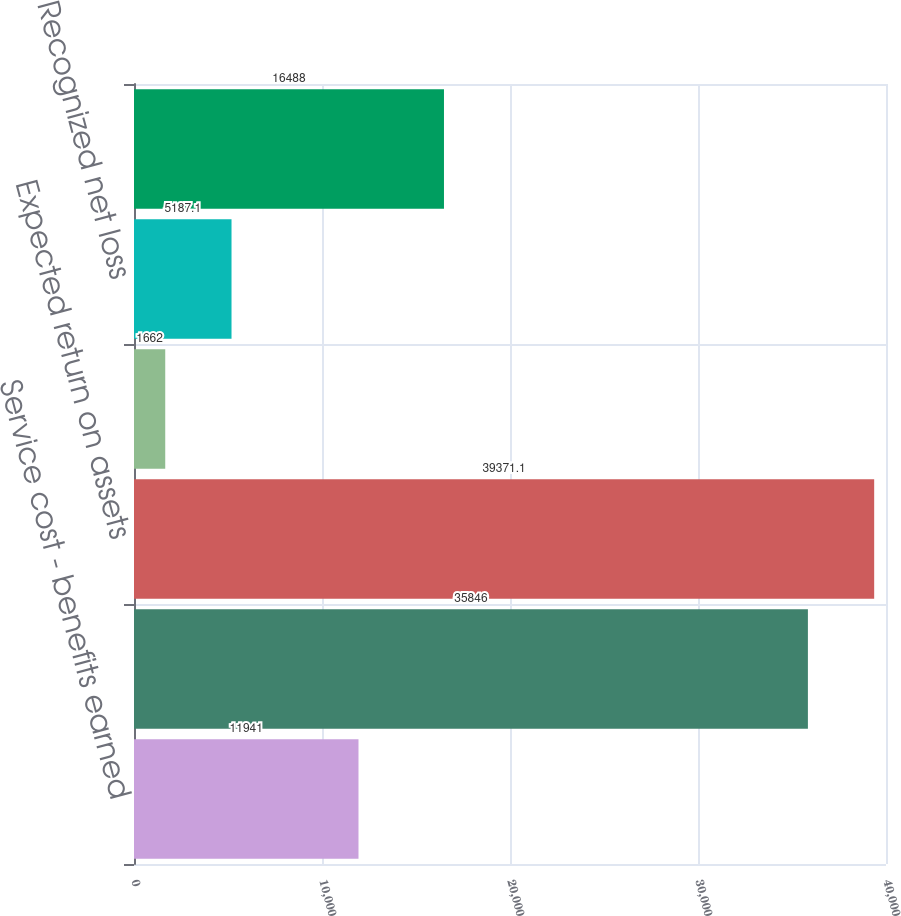Convert chart to OTSL. <chart><loc_0><loc_0><loc_500><loc_500><bar_chart><fcel>Service cost - benefits earned<fcel>Interest cost on projected<fcel>Expected return on assets<fcel>Amortization of prior service<fcel>Recognized net loss<fcel>Net pension cost<nl><fcel>11941<fcel>35846<fcel>39371.1<fcel>1662<fcel>5187.1<fcel>16488<nl></chart> 